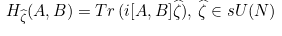Convert formula to latex. <formula><loc_0><loc_0><loc_500><loc_500>H _ { \widehat { \zeta } } ( A , B ) = T r \, ( i [ A , B ] \widehat { \zeta } ) , \, \widehat { \zeta } \in s U ( N ) \\</formula> 